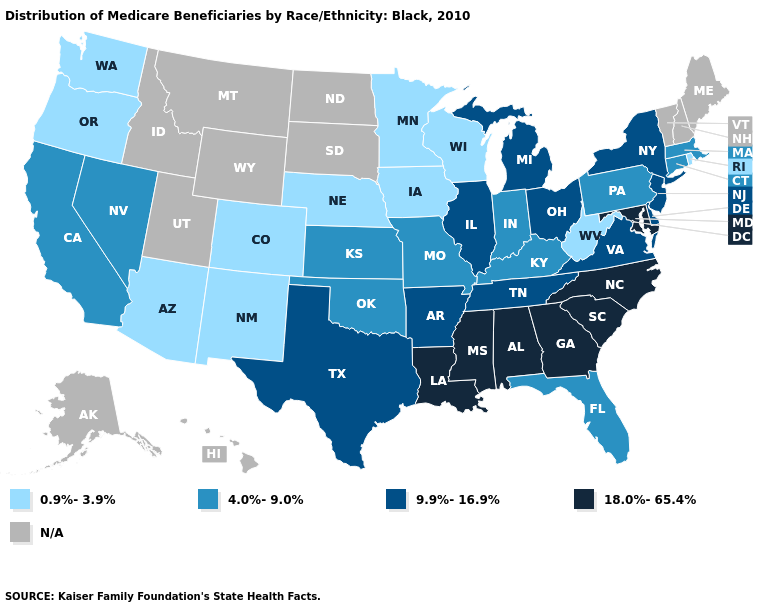What is the lowest value in states that border Washington?
Write a very short answer. 0.9%-3.9%. Name the states that have a value in the range N/A?
Write a very short answer. Alaska, Hawaii, Idaho, Maine, Montana, New Hampshire, North Dakota, South Dakota, Utah, Vermont, Wyoming. What is the value of Wyoming?
Short answer required. N/A. Does the first symbol in the legend represent the smallest category?
Concise answer only. Yes. How many symbols are there in the legend?
Be succinct. 5. Name the states that have a value in the range 18.0%-65.4%?
Short answer required. Alabama, Georgia, Louisiana, Maryland, Mississippi, North Carolina, South Carolina. Does the map have missing data?
Concise answer only. Yes. Does Iowa have the lowest value in the MidWest?
Quick response, please. Yes. Among the states that border Mississippi , which have the highest value?
Concise answer only. Alabama, Louisiana. Among the states that border North Carolina , which have the highest value?
Write a very short answer. Georgia, South Carolina. Name the states that have a value in the range 9.9%-16.9%?
Quick response, please. Arkansas, Delaware, Illinois, Michigan, New Jersey, New York, Ohio, Tennessee, Texas, Virginia. What is the value of North Dakota?
Keep it brief. N/A. 